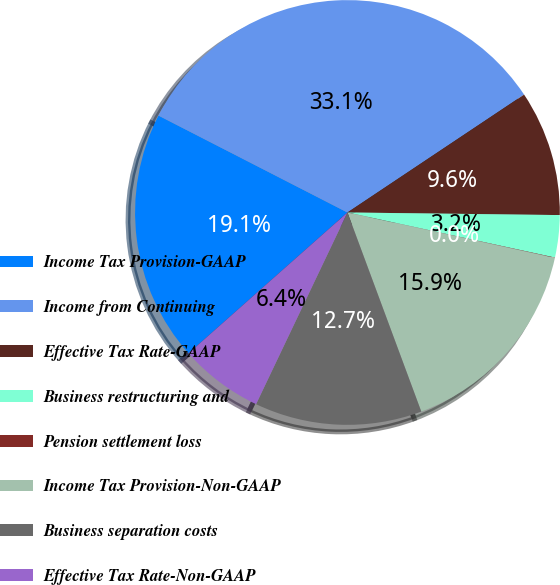<chart> <loc_0><loc_0><loc_500><loc_500><pie_chart><fcel>Income Tax Provision-GAAP<fcel>Income from Continuing<fcel>Effective Tax Rate-GAAP<fcel>Business restructuring and<fcel>Pension settlement loss<fcel>Income Tax Provision-Non-GAAP<fcel>Business separation costs<fcel>Effective Tax Rate-Non-GAAP<nl><fcel>19.08%<fcel>33.09%<fcel>9.56%<fcel>3.21%<fcel>0.03%<fcel>15.91%<fcel>12.73%<fcel>6.38%<nl></chart> 